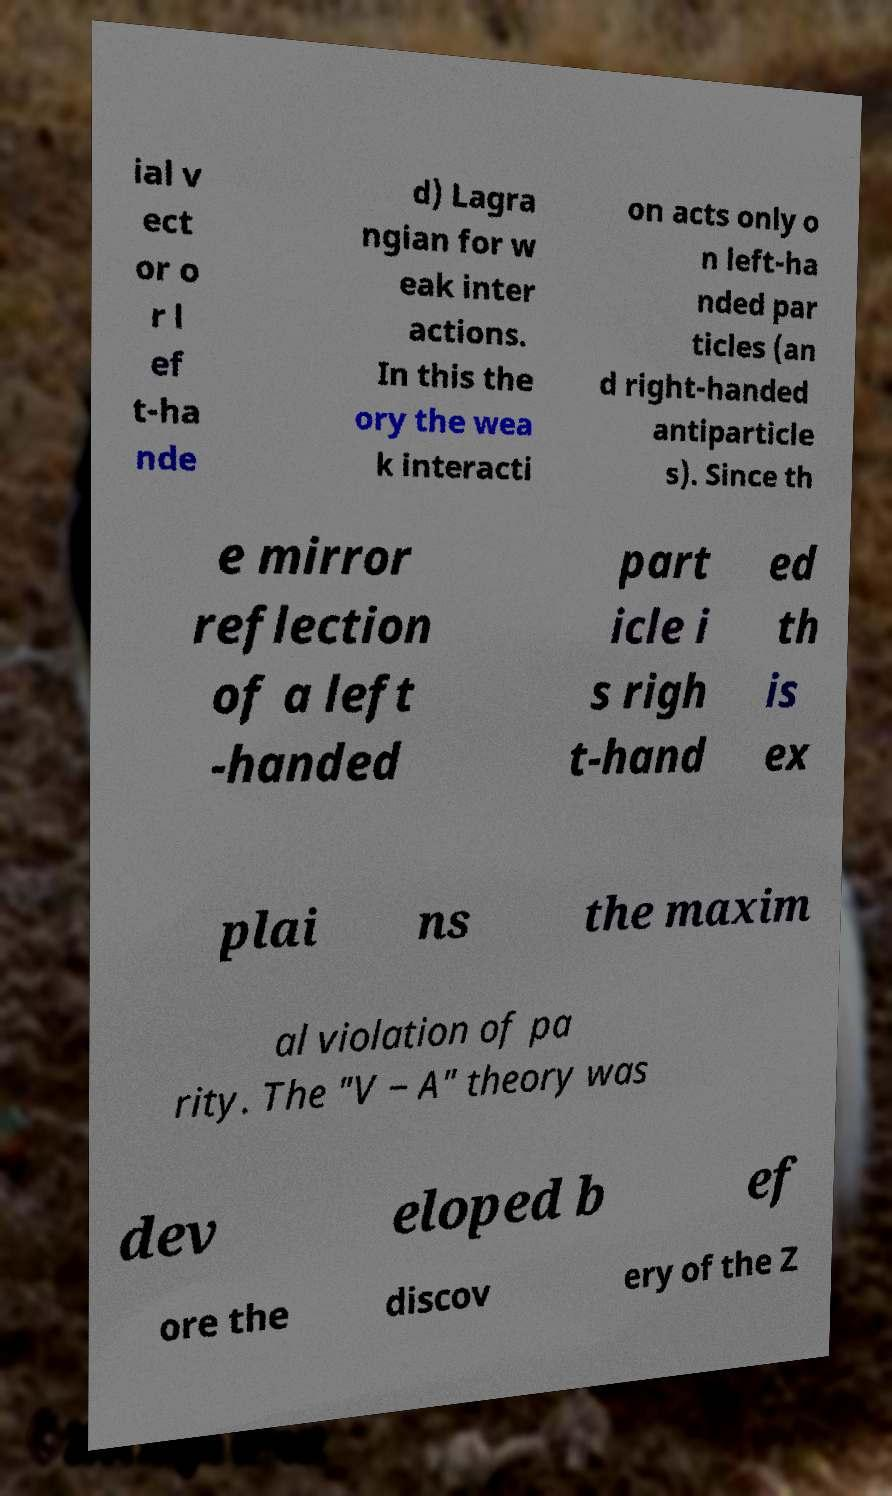I need the written content from this picture converted into text. Can you do that? ial v ect or o r l ef t-ha nde d) Lagra ngian for w eak inter actions. In this the ory the wea k interacti on acts only o n left-ha nded par ticles (an d right-handed antiparticle s). Since th e mirror reflection of a left -handed part icle i s righ t-hand ed th is ex plai ns the maxim al violation of pa rity. The "V − A" theory was dev eloped b ef ore the discov ery of the Z 